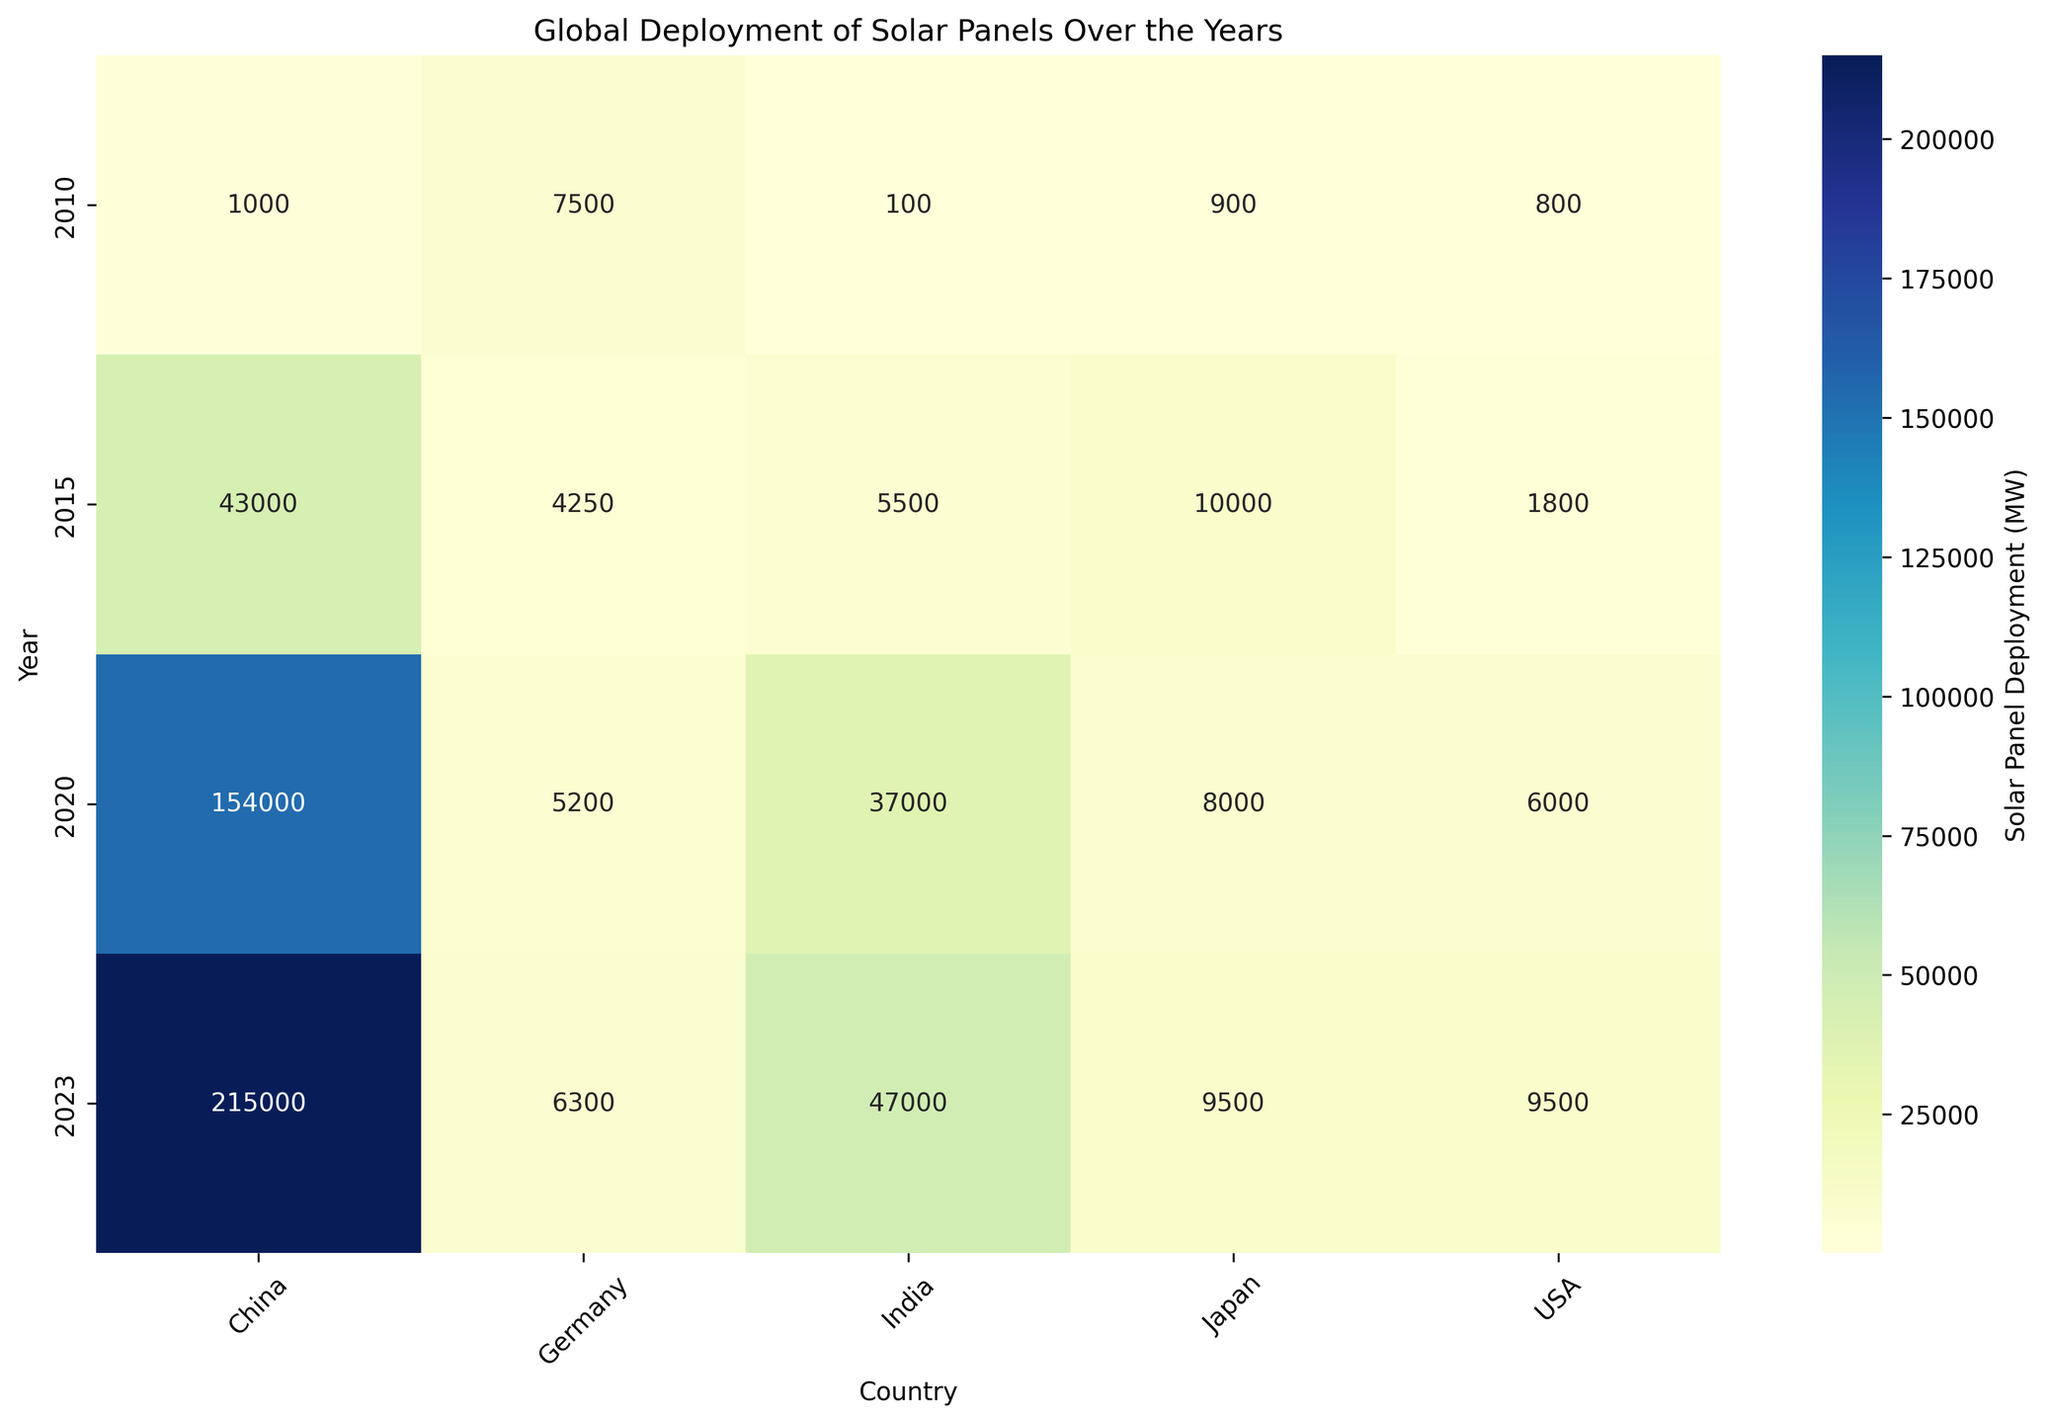Which country had the highest solar panel deployment in 2023? From the heatmap, locate the column for the year 2023 and identify which country has the deepest color, indicating the highest deployment number.
Answer: China What is the total solar panel deployment in MW for Germany across all displayed years? Add the deployment numbers for Germany from 2010, 2015, 2020, and 2023. Calculations are: 7500 + 4250 + 5200 + 6300 = 23250 MW.
Answer: 23250 MW How does the solar panel deployment in India in 2020 compare to Japan in the same year? Check the colors for both India and Japan in 2020 and compare the numbers. India has 37000 MW, Japan has 8000 MW, so India deployed more solar panels.
Answer: India has more What is the average solar panel deployment in MW for the USA over the years shown? Sum the deployment numbers for the USA from 2010, 2015, 2020, and 2023 and then divide by 4: (800 + 1800 + 6000 + 9500) / 4 = 4525 MW.
Answer: 4525 MW Which year shows the most significant increase in solar panel deployment for China? Compare the changes in deployment numbers for China between consecutive years. The increase is greatest from 2015 to 2020 (154000 - 43000 = 111000 MW).
Answer: 2015 to 2020 In which country did the solar panel deployment decrease from 2010 to 2015? Look for a negative change in deployment numbers between 2010 and 2015. Germany had a decrease from 7500 MW in 2010 to 4250 MW in 2015.
Answer: Germany What is the difference in solar panel deployment between USA and India in 2023? Calculate the absolute difference between the deployment numbers for the USA and India in 2023:
Answer: 9500 - 47000 = -37500 (or reflect that in absolute terms: 37500 MW) Which country had the most consistent solar panel deployment growth over the years shown? Compare the growth patterns for all countries and determine which has the most uniform rate of increase. The USA shows a consistent growth trajectory.
Answer: USA 